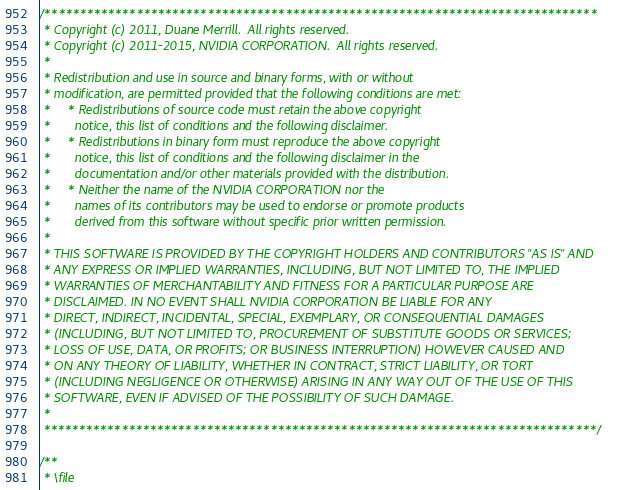Convert code to text. <code><loc_0><loc_0><loc_500><loc_500><_Cuda_>/******************************************************************************
 * Copyright (c) 2011, Duane Merrill.  All rights reserved.
 * Copyright (c) 2011-2015, NVIDIA CORPORATION.  All rights reserved.
 * 
 * Redistribution and use in source and binary forms, with or without
 * modification, are permitted provided that the following conditions are met:
 *     * Redistributions of source code must retain the above copyright
 *       notice, this list of conditions and the following disclaimer.
 *     * Redistributions in binary form must reproduce the above copyright
 *       notice, this list of conditions and the following disclaimer in the
 *       documentation and/or other materials provided with the distribution.
 *     * Neither the name of the NVIDIA CORPORATION nor the
 *       names of its contributors may be used to endorse or promote products
 *       derived from this software without specific prior written permission.
 * 
 * THIS SOFTWARE IS PROVIDED BY THE COPYRIGHT HOLDERS AND CONTRIBUTORS "AS IS" AND
 * ANY EXPRESS OR IMPLIED WARRANTIES, INCLUDING, BUT NOT LIMITED TO, THE IMPLIED
 * WARRANTIES OF MERCHANTABILITY AND FITNESS FOR A PARTICULAR PURPOSE ARE
 * DISCLAIMED. IN NO EVENT SHALL NVIDIA CORPORATION BE LIABLE FOR ANY
 * DIRECT, INDIRECT, INCIDENTAL, SPECIAL, EXEMPLARY, OR CONSEQUENTIAL DAMAGES
 * (INCLUDING, BUT NOT LIMITED TO, PROCUREMENT OF SUBSTITUTE GOODS OR SERVICES;
 * LOSS OF USE, DATA, OR PROFITS; OR BUSINESS INTERRUPTION) HOWEVER CAUSED AND
 * ON ANY THEORY OF LIABILITY, WHETHER IN CONTRACT, STRICT LIABILITY, OR TORT
 * (INCLUDING NEGLIGENCE OR OTHERWISE) ARISING IN ANY WAY OUT OF THE USE OF THIS
 * SOFTWARE, EVEN IF ADVISED OF THE POSSIBILITY OF SUCH DAMAGE.
 *
 ******************************************************************************/

/**
 * \file</code> 